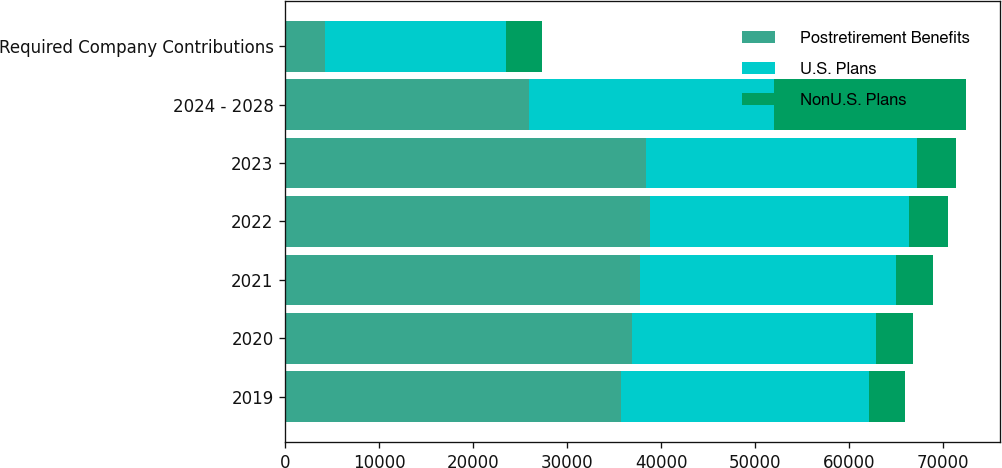Convert chart to OTSL. <chart><loc_0><loc_0><loc_500><loc_500><stacked_bar_chart><ecel><fcel>2019<fcel>2020<fcel>2021<fcel>2022<fcel>2023<fcel>2024 - 2028<fcel>Required Company Contributions<nl><fcel>Postretirement Benefits<fcel>35742<fcel>36918<fcel>37710<fcel>38823<fcel>38449<fcel>25991<fcel>4207<nl><fcel>U.S. Plans<fcel>26342<fcel>25991<fcel>27270<fcel>27589<fcel>28843<fcel>25991<fcel>19258<nl><fcel>NonU.S. Plans<fcel>3881<fcel>3940<fcel>4014<fcel>4081<fcel>4085<fcel>20449<fcel>3882<nl></chart> 